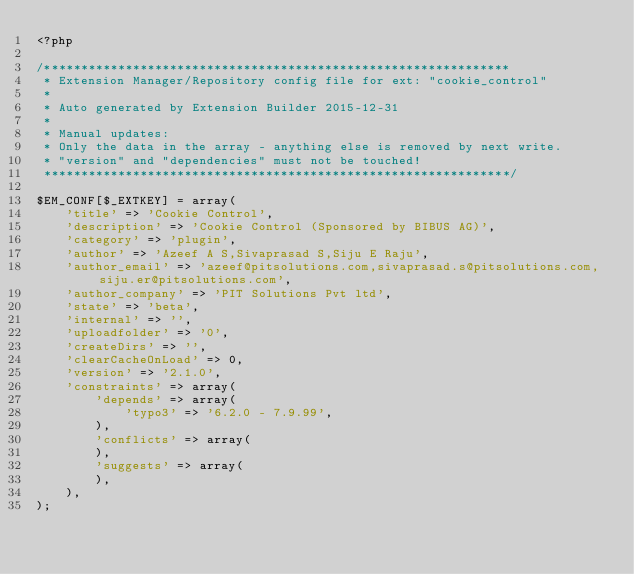<code> <loc_0><loc_0><loc_500><loc_500><_PHP_><?php

/***************************************************************
 * Extension Manager/Repository config file for ext: "cookie_control"
 *
 * Auto generated by Extension Builder 2015-12-31
 *
 * Manual updates:
 * Only the data in the array - anything else is removed by next write.
 * "version" and "dependencies" must not be touched!
 ***************************************************************/

$EM_CONF[$_EXTKEY] = array(
	'title' => 'Cookie Control',
	'description' => 'Cookie Control (Sponsored by BIBUS AG)',
	'category' => 'plugin',
	'author' => 'Azeef A S,Sivaprasad S,Siju E Raju',
	'author_email' => 'azeef@pitsolutions.com,sivaprasad.s@pitsolutions.com,siju.er@pitsolutions.com',
	'author_company' => 'PIT Solutions Pvt ltd',
	'state' => 'beta',
	'internal' => '',
	'uploadfolder' => '0',
	'createDirs' => '',
	'clearCacheOnLoad' => 0,
	'version' => '2.1.0',
	'constraints' => array(
		'depends' => array(
			'typo3' => '6.2.0 - 7.9.99',
		),
		'conflicts' => array(
		),
		'suggests' => array(
		),
	),
);</code> 